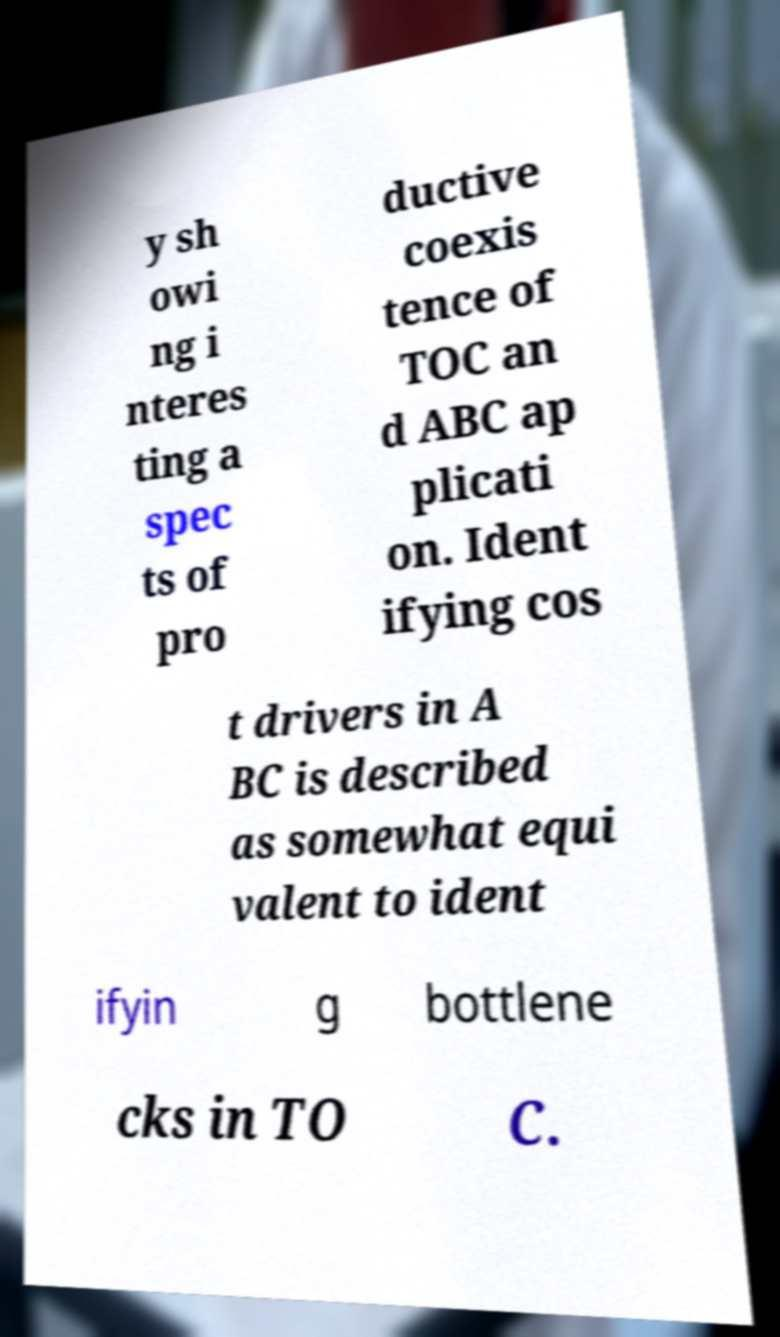There's text embedded in this image that I need extracted. Can you transcribe it verbatim? y sh owi ng i nteres ting a spec ts of pro ductive coexis tence of TOC an d ABC ap plicati on. Ident ifying cos t drivers in A BC is described as somewhat equi valent to ident ifyin g bottlene cks in TO C. 